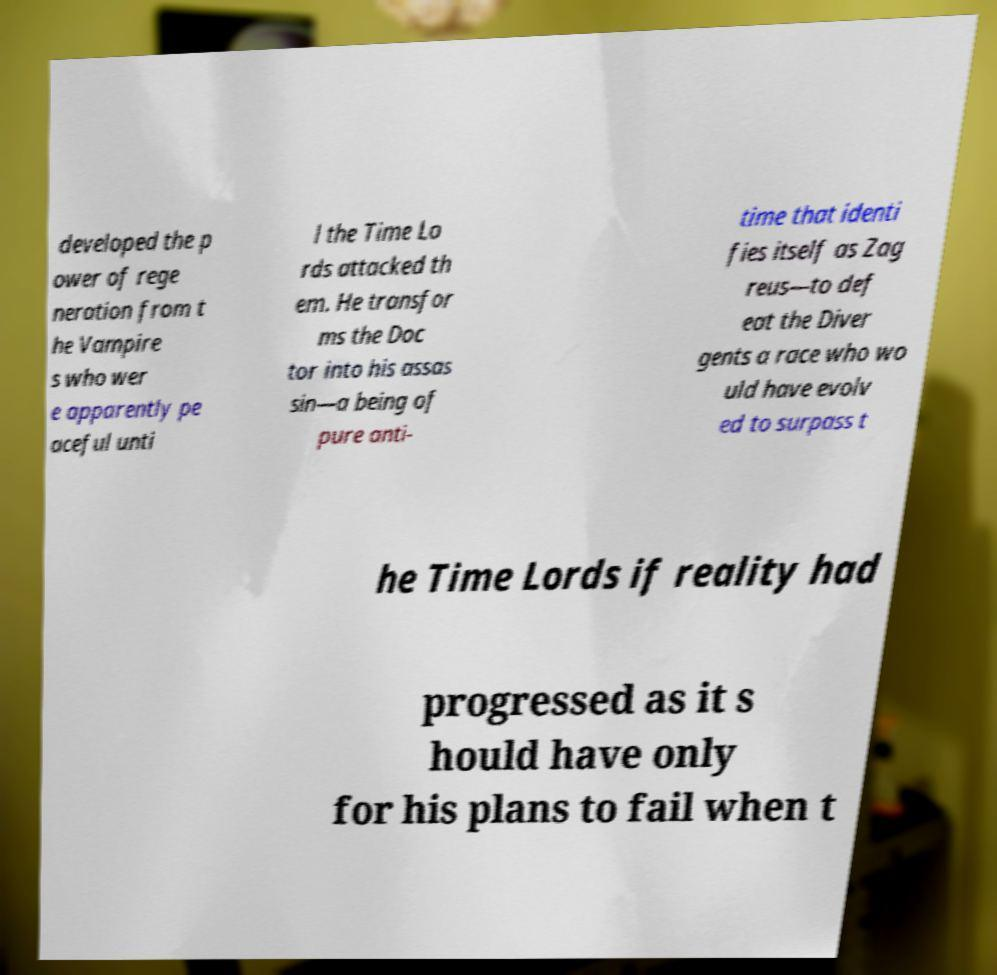For documentation purposes, I need the text within this image transcribed. Could you provide that? developed the p ower of rege neration from t he Vampire s who wer e apparently pe aceful unti l the Time Lo rds attacked th em. He transfor ms the Doc tor into his assas sin—a being of pure anti- time that identi fies itself as Zag reus—to def eat the Diver gents a race who wo uld have evolv ed to surpass t he Time Lords if reality had progressed as it s hould have only for his plans to fail when t 